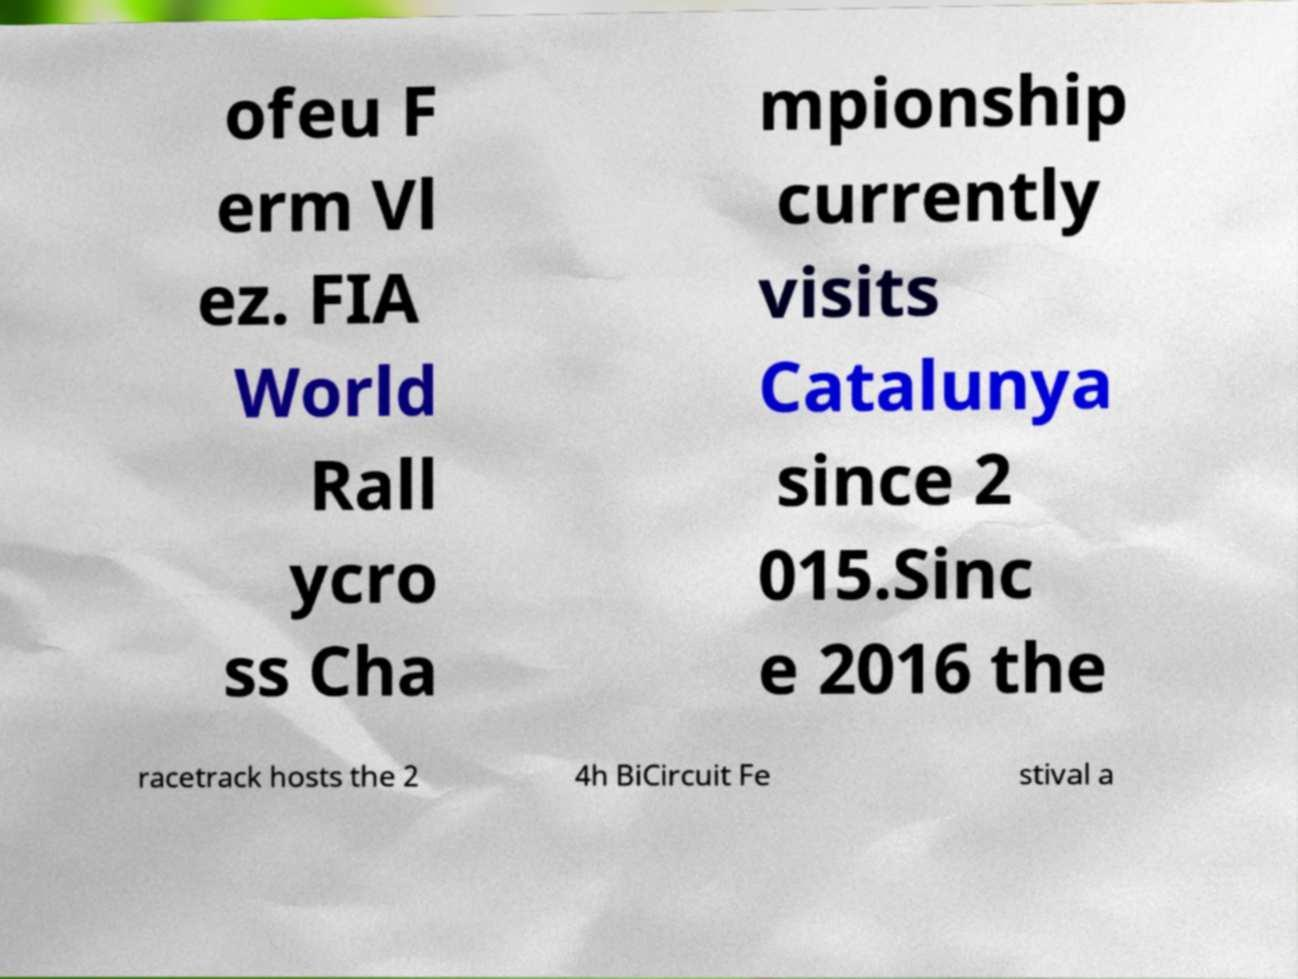Could you assist in decoding the text presented in this image and type it out clearly? ofeu F erm Vl ez. FIA World Rall ycro ss Cha mpionship currently visits Catalunya since 2 015.Sinc e 2016 the racetrack hosts the 2 4h BiCircuit Fe stival a 